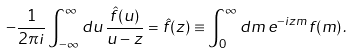<formula> <loc_0><loc_0><loc_500><loc_500>- \frac { 1 } { 2 \pi i } \int _ { - \infty } ^ { \infty } d u \, \frac { \hat { f } ( u ) } { u - z } = \hat { f } ( z ) \equiv \int _ { 0 } ^ { \infty } d m \, e ^ { - i z m } f ( m ) \, .</formula> 